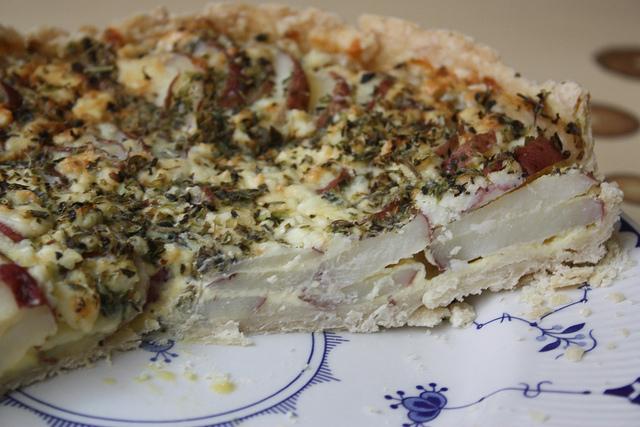How many people would the remainder of this food serve?
Short answer required. 4. How many calories would a single serving of this food contain?
Concise answer only. 700. Is more than half of this dish already gone?
Be succinct. No. Would this meal be something you might eat outside on a picnic?
Give a very brief answer. No. 